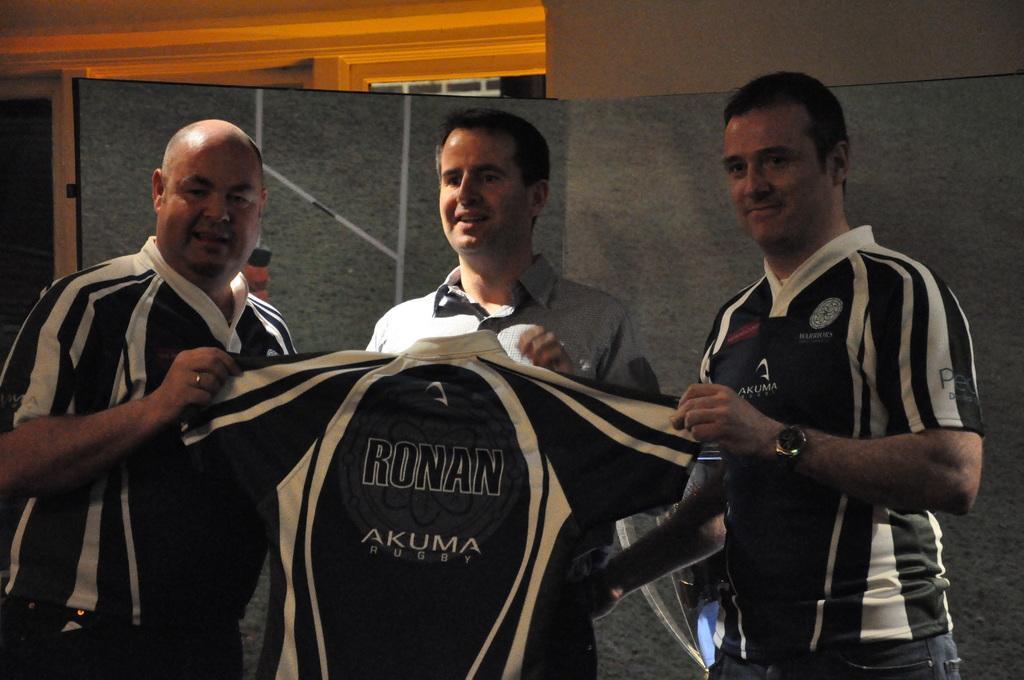Can you describe this image briefly? In this image there are three man holding a T-shirt, in the background there is a wall. 